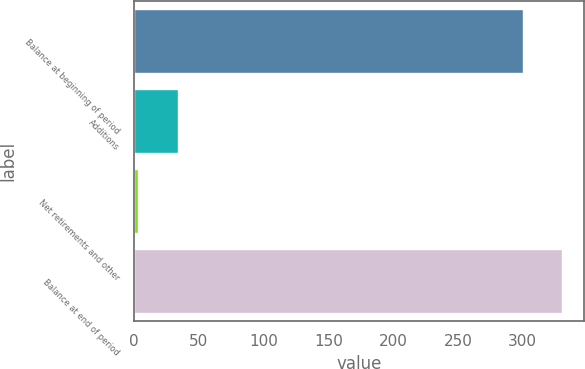<chart> <loc_0><loc_0><loc_500><loc_500><bar_chart><fcel>Balance at beginning of period<fcel>Additions<fcel>Net retirements and other<fcel>Balance at end of period<nl><fcel>300<fcel>33.7<fcel>3<fcel>330.7<nl></chart> 